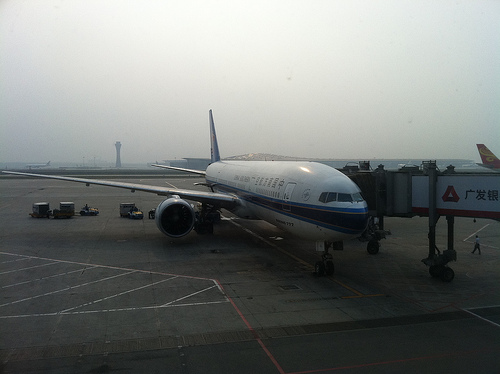<image>
Is the person on the airplane? No. The person is not positioned on the airplane. They may be near each other, but the person is not supported by or resting on top of the airplane. 